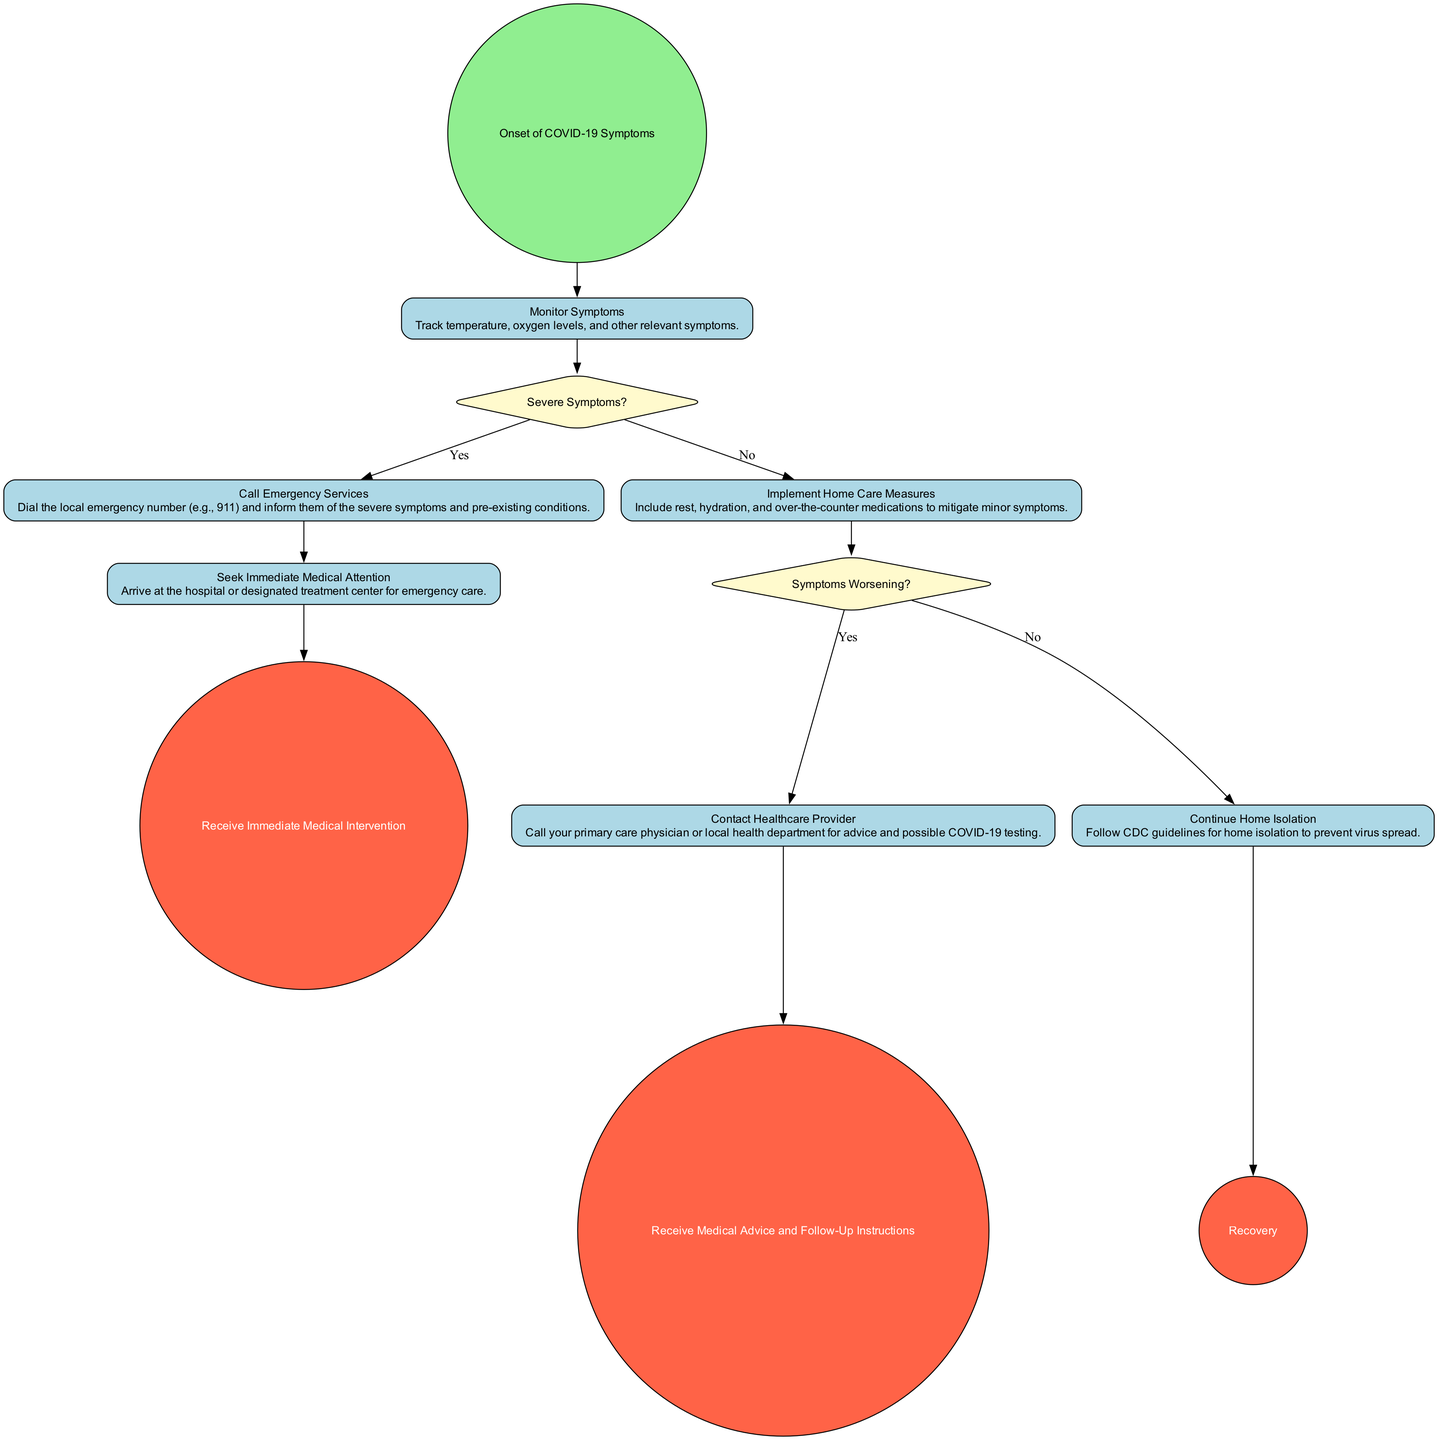What is the starting event in the diagram? The starting event is labeled "Onset of COVID-19 Symptoms." This is the first node in the diagram and indicates the beginning of the process.
Answer: Onset of COVID-19 Symptoms How many decision nodes are in the diagram? There are two decision nodes in the diagram: "Severe Symptoms?" and "Symptoms Worsening?" Each decision node presents a condition that guides the flow of activities based on responses.
Answer: 2 What activity follows "Monitor Symptoms" if severe symptoms are present? If severe symptoms are present, the next activity is "Call Emergency Services." This is determined by the outgoing flow from the decision node "Severe Symptoms?" which directs towards this activity when the answer is "Yes."
Answer: Call Emergency Services What action is taken if symptoms are worsening? If symptoms are worsening, the next action is to "Contact Healthcare Provider." This is the branch that follows the decision node "Symptoms Worsening?" when the answer is "Yes."
Answer: Contact Healthcare Provider What is the final outcome of the emergency response plan? The final outcome of the emergency response plan is "Recovery." This is reached by following the appropriate paths through the diagram based on the decisions and activities conducted throughout the process.
Answer: Recovery What happens if there are no severe symptoms after monitoring? If there are no severe symptoms after monitoring, the subsequent action is to "Implement Home Care Measures." This is defined by the outgoing flow from the "Severe Symptoms?" decision node towards this activity when the answer is "No."
Answer: Implement Home Care Measures 